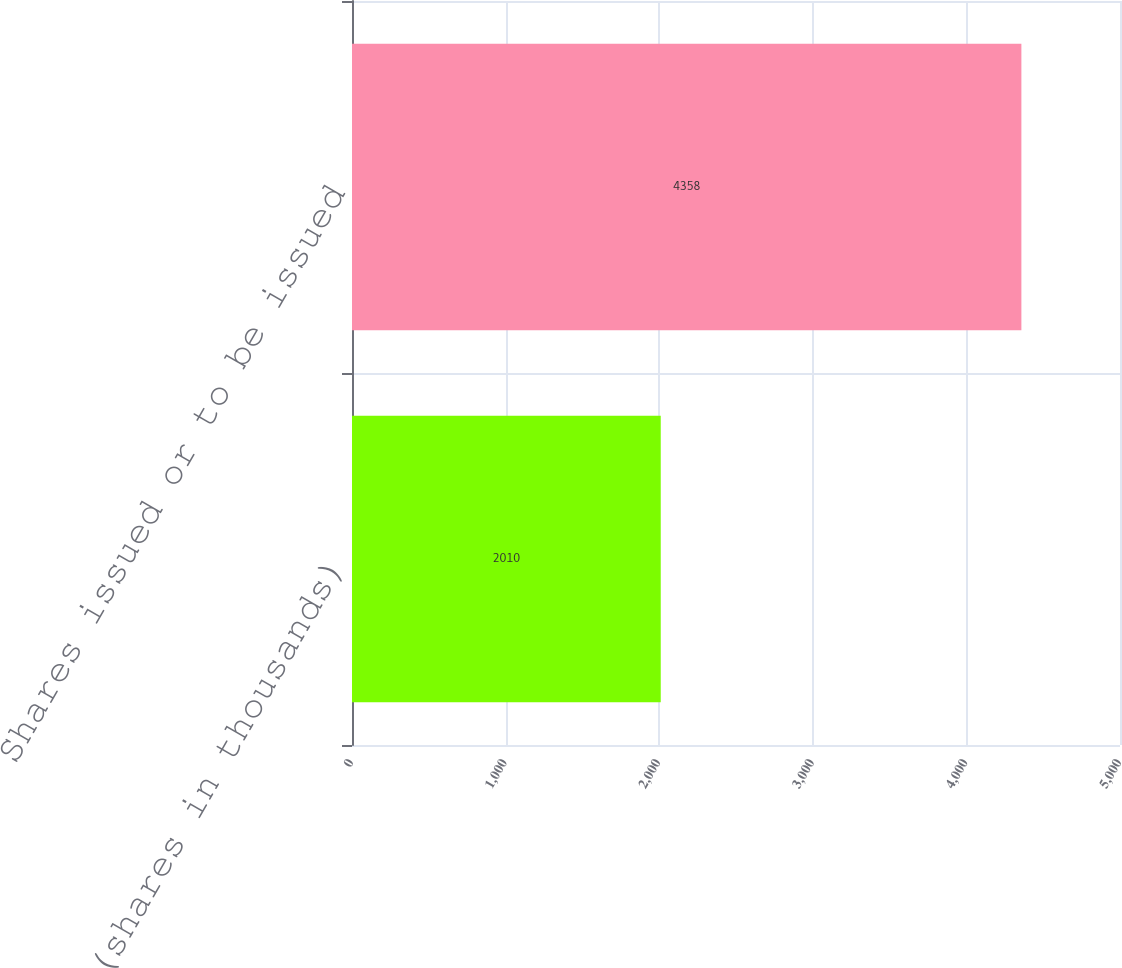Convert chart. <chart><loc_0><loc_0><loc_500><loc_500><bar_chart><fcel>(shares in thousands)<fcel>Shares issued or to be issued<nl><fcel>2010<fcel>4358<nl></chart> 